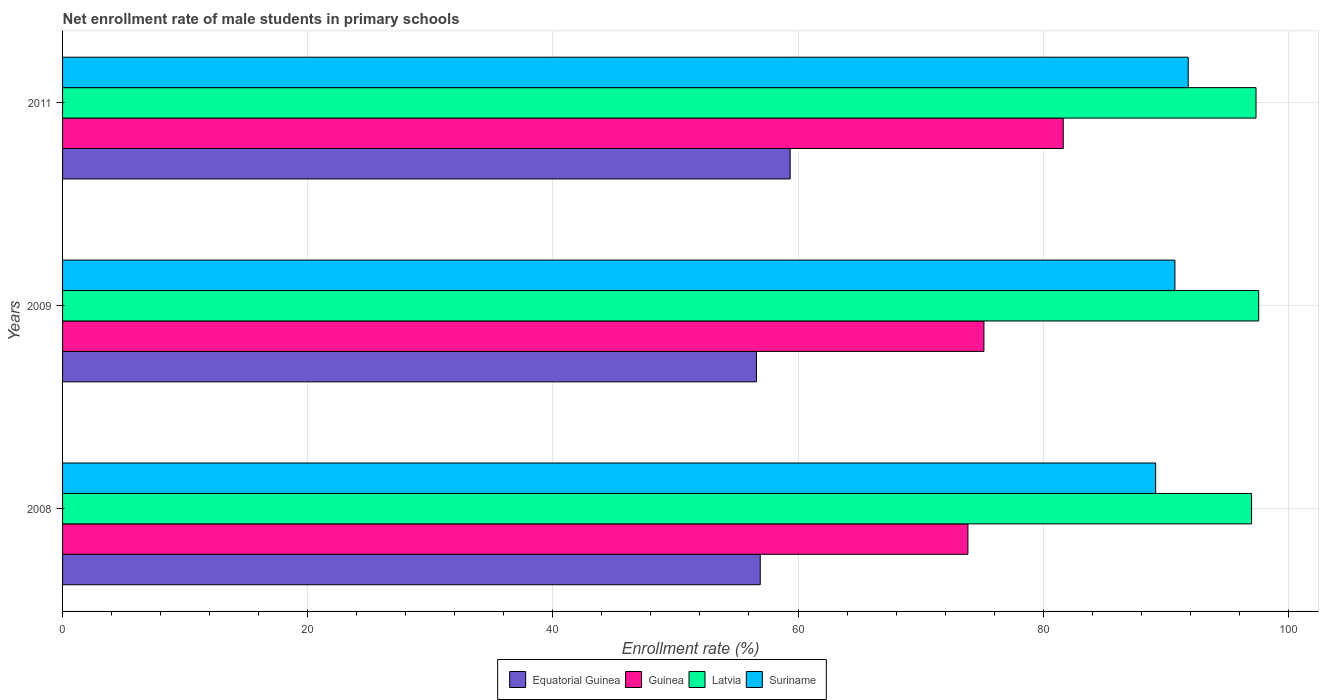How many different coloured bars are there?
Give a very brief answer. 4. How many groups of bars are there?
Provide a short and direct response. 3. How many bars are there on the 3rd tick from the top?
Give a very brief answer. 4. In how many cases, is the number of bars for a given year not equal to the number of legend labels?
Make the answer very short. 0. What is the net enrollment rate of male students in primary schools in Guinea in 2011?
Provide a short and direct response. 81.64. Across all years, what is the maximum net enrollment rate of male students in primary schools in Equatorial Guinea?
Give a very brief answer. 59.36. Across all years, what is the minimum net enrollment rate of male students in primary schools in Latvia?
Offer a terse response. 97. In which year was the net enrollment rate of male students in primary schools in Equatorial Guinea maximum?
Your response must be concise. 2011. What is the total net enrollment rate of male students in primary schools in Latvia in the graph?
Ensure brevity in your answer.  291.96. What is the difference between the net enrollment rate of male students in primary schools in Guinea in 2008 and that in 2011?
Your answer should be very brief. -7.78. What is the difference between the net enrollment rate of male students in primary schools in Equatorial Guinea in 2009 and the net enrollment rate of male students in primary schools in Suriname in 2011?
Ensure brevity in your answer.  -35.22. What is the average net enrollment rate of male students in primary schools in Guinea per year?
Provide a succinct answer. 76.89. In the year 2009, what is the difference between the net enrollment rate of male students in primary schools in Suriname and net enrollment rate of male students in primary schools in Guinea?
Keep it short and to the point. 15.58. What is the ratio of the net enrollment rate of male students in primary schools in Suriname in 2009 to that in 2011?
Your response must be concise. 0.99. Is the difference between the net enrollment rate of male students in primary schools in Suriname in 2008 and 2011 greater than the difference between the net enrollment rate of male students in primary schools in Guinea in 2008 and 2011?
Make the answer very short. Yes. What is the difference between the highest and the second highest net enrollment rate of male students in primary schools in Guinea?
Keep it short and to the point. 6.47. What is the difference between the highest and the lowest net enrollment rate of male students in primary schools in Latvia?
Provide a succinct answer. 0.58. Is it the case that in every year, the sum of the net enrollment rate of male students in primary schools in Guinea and net enrollment rate of male students in primary schools in Suriname is greater than the sum of net enrollment rate of male students in primary schools in Latvia and net enrollment rate of male students in primary schools in Equatorial Guinea?
Your response must be concise. Yes. What does the 4th bar from the top in 2011 represents?
Your answer should be very brief. Equatorial Guinea. What does the 1st bar from the bottom in 2008 represents?
Ensure brevity in your answer.  Equatorial Guinea. Are all the bars in the graph horizontal?
Your answer should be very brief. Yes. Does the graph contain grids?
Ensure brevity in your answer.  Yes. How are the legend labels stacked?
Ensure brevity in your answer.  Horizontal. What is the title of the graph?
Make the answer very short. Net enrollment rate of male students in primary schools. What is the label or title of the X-axis?
Offer a very short reply. Enrollment rate (%). What is the label or title of the Y-axis?
Provide a short and direct response. Years. What is the Enrollment rate (%) of Equatorial Guinea in 2008?
Your answer should be very brief. 56.92. What is the Enrollment rate (%) in Guinea in 2008?
Your answer should be very brief. 73.86. What is the Enrollment rate (%) in Latvia in 2008?
Offer a terse response. 97. What is the Enrollment rate (%) in Suriname in 2008?
Provide a succinct answer. 89.18. What is the Enrollment rate (%) in Equatorial Guinea in 2009?
Keep it short and to the point. 56.61. What is the Enrollment rate (%) of Guinea in 2009?
Offer a very short reply. 75.17. What is the Enrollment rate (%) of Latvia in 2009?
Ensure brevity in your answer.  97.58. What is the Enrollment rate (%) in Suriname in 2009?
Ensure brevity in your answer.  90.75. What is the Enrollment rate (%) of Equatorial Guinea in 2011?
Provide a succinct answer. 59.36. What is the Enrollment rate (%) of Guinea in 2011?
Make the answer very short. 81.64. What is the Enrollment rate (%) in Latvia in 2011?
Give a very brief answer. 97.37. What is the Enrollment rate (%) in Suriname in 2011?
Provide a succinct answer. 91.84. Across all years, what is the maximum Enrollment rate (%) of Equatorial Guinea?
Your answer should be very brief. 59.36. Across all years, what is the maximum Enrollment rate (%) of Guinea?
Give a very brief answer. 81.64. Across all years, what is the maximum Enrollment rate (%) of Latvia?
Provide a succinct answer. 97.58. Across all years, what is the maximum Enrollment rate (%) in Suriname?
Your answer should be very brief. 91.84. Across all years, what is the minimum Enrollment rate (%) of Equatorial Guinea?
Ensure brevity in your answer.  56.61. Across all years, what is the minimum Enrollment rate (%) in Guinea?
Provide a short and direct response. 73.86. Across all years, what is the minimum Enrollment rate (%) in Latvia?
Offer a very short reply. 97. Across all years, what is the minimum Enrollment rate (%) in Suriname?
Give a very brief answer. 89.18. What is the total Enrollment rate (%) in Equatorial Guinea in the graph?
Your response must be concise. 172.89. What is the total Enrollment rate (%) in Guinea in the graph?
Your answer should be compact. 230.67. What is the total Enrollment rate (%) in Latvia in the graph?
Provide a short and direct response. 291.96. What is the total Enrollment rate (%) of Suriname in the graph?
Provide a succinct answer. 271.76. What is the difference between the Enrollment rate (%) of Equatorial Guinea in 2008 and that in 2009?
Make the answer very short. 0.31. What is the difference between the Enrollment rate (%) of Guinea in 2008 and that in 2009?
Your answer should be compact. -1.31. What is the difference between the Enrollment rate (%) of Latvia in 2008 and that in 2009?
Offer a terse response. -0.58. What is the difference between the Enrollment rate (%) in Suriname in 2008 and that in 2009?
Keep it short and to the point. -1.57. What is the difference between the Enrollment rate (%) in Equatorial Guinea in 2008 and that in 2011?
Ensure brevity in your answer.  -2.44. What is the difference between the Enrollment rate (%) in Guinea in 2008 and that in 2011?
Offer a very short reply. -7.78. What is the difference between the Enrollment rate (%) of Latvia in 2008 and that in 2011?
Offer a very short reply. -0.36. What is the difference between the Enrollment rate (%) of Suriname in 2008 and that in 2011?
Offer a very short reply. -2.66. What is the difference between the Enrollment rate (%) of Equatorial Guinea in 2009 and that in 2011?
Ensure brevity in your answer.  -2.75. What is the difference between the Enrollment rate (%) of Guinea in 2009 and that in 2011?
Offer a very short reply. -6.47. What is the difference between the Enrollment rate (%) of Latvia in 2009 and that in 2011?
Ensure brevity in your answer.  0.22. What is the difference between the Enrollment rate (%) of Suriname in 2009 and that in 2011?
Your answer should be compact. -1.09. What is the difference between the Enrollment rate (%) in Equatorial Guinea in 2008 and the Enrollment rate (%) in Guinea in 2009?
Ensure brevity in your answer.  -18.25. What is the difference between the Enrollment rate (%) of Equatorial Guinea in 2008 and the Enrollment rate (%) of Latvia in 2009?
Provide a short and direct response. -40.67. What is the difference between the Enrollment rate (%) of Equatorial Guinea in 2008 and the Enrollment rate (%) of Suriname in 2009?
Make the answer very short. -33.83. What is the difference between the Enrollment rate (%) of Guinea in 2008 and the Enrollment rate (%) of Latvia in 2009?
Provide a succinct answer. -23.72. What is the difference between the Enrollment rate (%) of Guinea in 2008 and the Enrollment rate (%) of Suriname in 2009?
Provide a short and direct response. -16.89. What is the difference between the Enrollment rate (%) of Latvia in 2008 and the Enrollment rate (%) of Suriname in 2009?
Your response must be concise. 6.26. What is the difference between the Enrollment rate (%) of Equatorial Guinea in 2008 and the Enrollment rate (%) of Guinea in 2011?
Offer a terse response. -24.72. What is the difference between the Enrollment rate (%) of Equatorial Guinea in 2008 and the Enrollment rate (%) of Latvia in 2011?
Ensure brevity in your answer.  -40.45. What is the difference between the Enrollment rate (%) of Equatorial Guinea in 2008 and the Enrollment rate (%) of Suriname in 2011?
Your answer should be compact. -34.92. What is the difference between the Enrollment rate (%) of Guinea in 2008 and the Enrollment rate (%) of Latvia in 2011?
Ensure brevity in your answer.  -23.5. What is the difference between the Enrollment rate (%) in Guinea in 2008 and the Enrollment rate (%) in Suriname in 2011?
Keep it short and to the point. -17.97. What is the difference between the Enrollment rate (%) of Latvia in 2008 and the Enrollment rate (%) of Suriname in 2011?
Provide a succinct answer. 5.17. What is the difference between the Enrollment rate (%) of Equatorial Guinea in 2009 and the Enrollment rate (%) of Guinea in 2011?
Offer a very short reply. -25.03. What is the difference between the Enrollment rate (%) in Equatorial Guinea in 2009 and the Enrollment rate (%) in Latvia in 2011?
Keep it short and to the point. -40.76. What is the difference between the Enrollment rate (%) of Equatorial Guinea in 2009 and the Enrollment rate (%) of Suriname in 2011?
Offer a very short reply. -35.22. What is the difference between the Enrollment rate (%) in Guinea in 2009 and the Enrollment rate (%) in Latvia in 2011?
Ensure brevity in your answer.  -22.2. What is the difference between the Enrollment rate (%) of Guinea in 2009 and the Enrollment rate (%) of Suriname in 2011?
Your answer should be compact. -16.67. What is the difference between the Enrollment rate (%) of Latvia in 2009 and the Enrollment rate (%) of Suriname in 2011?
Make the answer very short. 5.75. What is the average Enrollment rate (%) in Equatorial Guinea per year?
Make the answer very short. 57.63. What is the average Enrollment rate (%) in Guinea per year?
Make the answer very short. 76.89. What is the average Enrollment rate (%) in Latvia per year?
Your answer should be compact. 97.32. What is the average Enrollment rate (%) in Suriname per year?
Ensure brevity in your answer.  90.59. In the year 2008, what is the difference between the Enrollment rate (%) in Equatorial Guinea and Enrollment rate (%) in Guinea?
Offer a very short reply. -16.95. In the year 2008, what is the difference between the Enrollment rate (%) of Equatorial Guinea and Enrollment rate (%) of Latvia?
Keep it short and to the point. -40.09. In the year 2008, what is the difference between the Enrollment rate (%) in Equatorial Guinea and Enrollment rate (%) in Suriname?
Your answer should be compact. -32.26. In the year 2008, what is the difference between the Enrollment rate (%) of Guinea and Enrollment rate (%) of Latvia?
Your response must be concise. -23.14. In the year 2008, what is the difference between the Enrollment rate (%) in Guinea and Enrollment rate (%) in Suriname?
Your response must be concise. -15.31. In the year 2008, what is the difference between the Enrollment rate (%) of Latvia and Enrollment rate (%) of Suriname?
Your answer should be very brief. 7.83. In the year 2009, what is the difference between the Enrollment rate (%) in Equatorial Guinea and Enrollment rate (%) in Guinea?
Ensure brevity in your answer.  -18.56. In the year 2009, what is the difference between the Enrollment rate (%) of Equatorial Guinea and Enrollment rate (%) of Latvia?
Keep it short and to the point. -40.97. In the year 2009, what is the difference between the Enrollment rate (%) in Equatorial Guinea and Enrollment rate (%) in Suriname?
Offer a terse response. -34.14. In the year 2009, what is the difference between the Enrollment rate (%) of Guinea and Enrollment rate (%) of Latvia?
Give a very brief answer. -22.41. In the year 2009, what is the difference between the Enrollment rate (%) of Guinea and Enrollment rate (%) of Suriname?
Give a very brief answer. -15.58. In the year 2009, what is the difference between the Enrollment rate (%) in Latvia and Enrollment rate (%) in Suriname?
Ensure brevity in your answer.  6.84. In the year 2011, what is the difference between the Enrollment rate (%) in Equatorial Guinea and Enrollment rate (%) in Guinea?
Offer a very short reply. -22.28. In the year 2011, what is the difference between the Enrollment rate (%) in Equatorial Guinea and Enrollment rate (%) in Latvia?
Give a very brief answer. -38.01. In the year 2011, what is the difference between the Enrollment rate (%) in Equatorial Guinea and Enrollment rate (%) in Suriname?
Provide a succinct answer. -32.47. In the year 2011, what is the difference between the Enrollment rate (%) in Guinea and Enrollment rate (%) in Latvia?
Give a very brief answer. -15.73. In the year 2011, what is the difference between the Enrollment rate (%) in Guinea and Enrollment rate (%) in Suriname?
Your answer should be very brief. -10.2. In the year 2011, what is the difference between the Enrollment rate (%) of Latvia and Enrollment rate (%) of Suriname?
Provide a short and direct response. 5.53. What is the ratio of the Enrollment rate (%) in Equatorial Guinea in 2008 to that in 2009?
Give a very brief answer. 1.01. What is the ratio of the Enrollment rate (%) in Guinea in 2008 to that in 2009?
Your answer should be compact. 0.98. What is the ratio of the Enrollment rate (%) in Suriname in 2008 to that in 2009?
Your answer should be compact. 0.98. What is the ratio of the Enrollment rate (%) of Equatorial Guinea in 2008 to that in 2011?
Make the answer very short. 0.96. What is the ratio of the Enrollment rate (%) in Guinea in 2008 to that in 2011?
Offer a very short reply. 0.9. What is the ratio of the Enrollment rate (%) in Latvia in 2008 to that in 2011?
Your answer should be compact. 1. What is the ratio of the Enrollment rate (%) in Suriname in 2008 to that in 2011?
Keep it short and to the point. 0.97. What is the ratio of the Enrollment rate (%) in Equatorial Guinea in 2009 to that in 2011?
Offer a very short reply. 0.95. What is the ratio of the Enrollment rate (%) in Guinea in 2009 to that in 2011?
Your answer should be compact. 0.92. What is the difference between the highest and the second highest Enrollment rate (%) in Equatorial Guinea?
Offer a very short reply. 2.44. What is the difference between the highest and the second highest Enrollment rate (%) of Guinea?
Offer a very short reply. 6.47. What is the difference between the highest and the second highest Enrollment rate (%) of Latvia?
Give a very brief answer. 0.22. What is the difference between the highest and the second highest Enrollment rate (%) of Suriname?
Give a very brief answer. 1.09. What is the difference between the highest and the lowest Enrollment rate (%) in Equatorial Guinea?
Offer a terse response. 2.75. What is the difference between the highest and the lowest Enrollment rate (%) of Guinea?
Give a very brief answer. 7.78. What is the difference between the highest and the lowest Enrollment rate (%) of Latvia?
Keep it short and to the point. 0.58. What is the difference between the highest and the lowest Enrollment rate (%) in Suriname?
Your answer should be very brief. 2.66. 